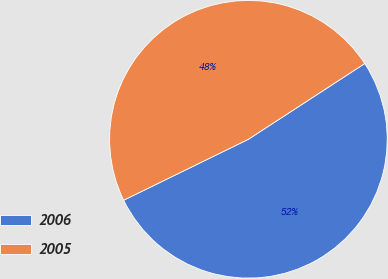<chart> <loc_0><loc_0><loc_500><loc_500><pie_chart><fcel>2006<fcel>2005<nl><fcel>51.95%<fcel>48.05%<nl></chart> 